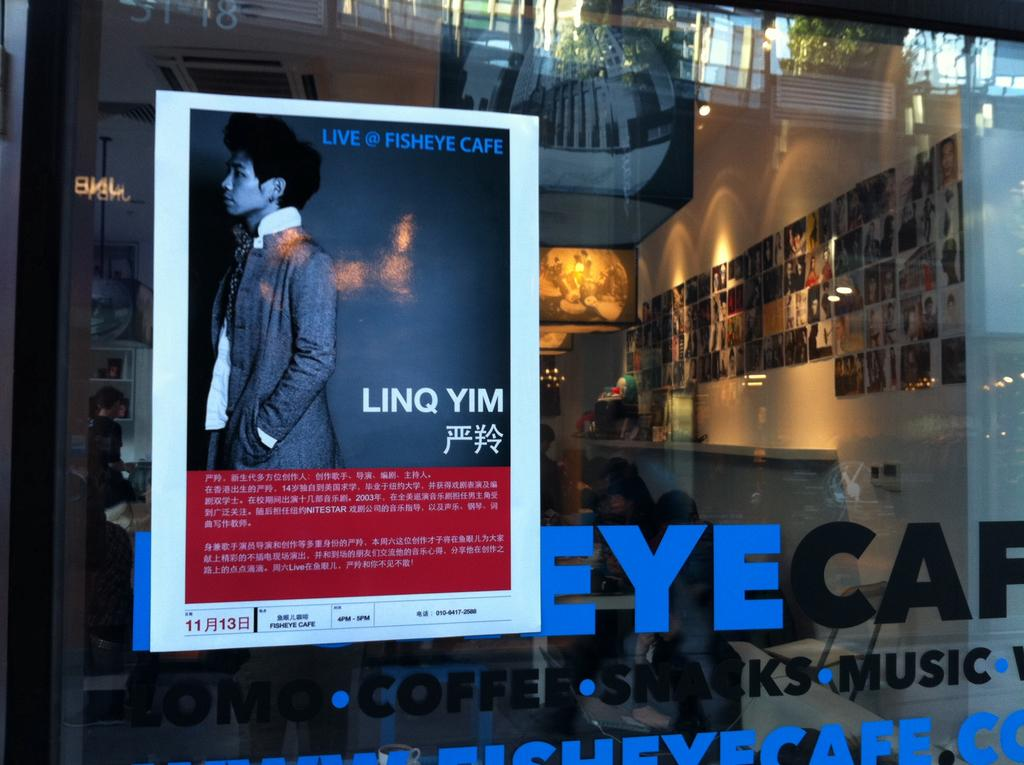<image>
Give a short and clear explanation of the subsequent image. A flyer in a window promoting Linq Yim. 